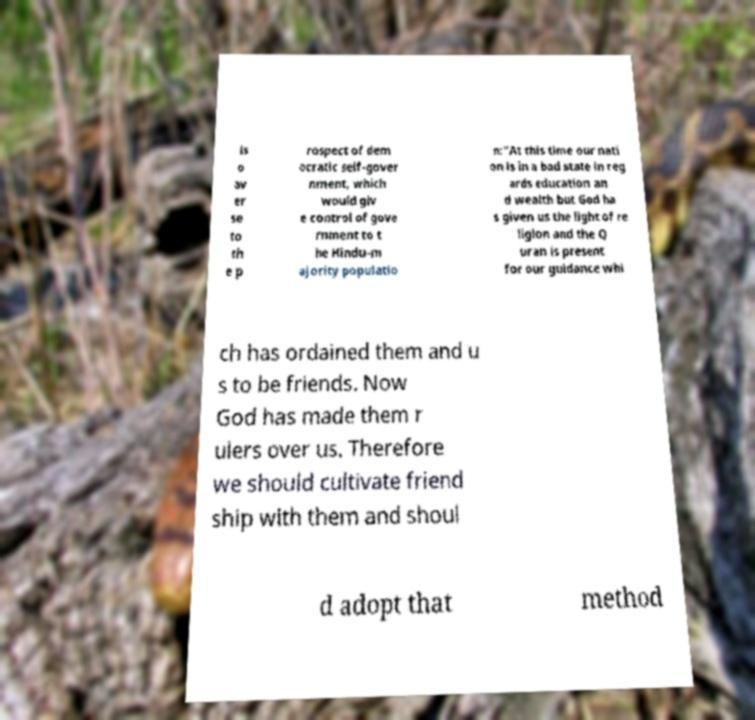For documentation purposes, I need the text within this image transcribed. Could you provide that? ls o av er se to th e p rospect of dem ocratic self-gover nment, which would giv e control of gove rnment to t he Hindu-m ajority populatio n:"At this time our nati on is in a bad state in reg ards education an d wealth but God ha s given us the light of re ligion and the Q uran is present for our guidance whi ch has ordained them and u s to be friends. Now God has made them r ulers over us. Therefore we should cultivate friend ship with them and shoul d adopt that method 